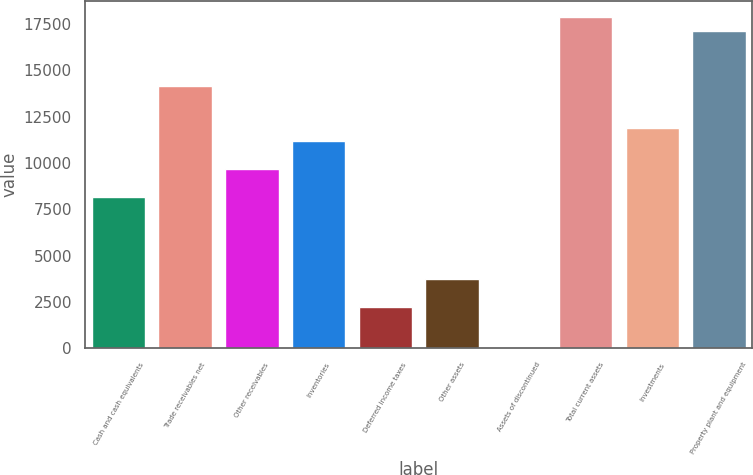<chart> <loc_0><loc_0><loc_500><loc_500><bar_chart><fcel>Cash and cash equivalents<fcel>Trade receivables net<fcel>Other receivables<fcel>Inventories<fcel>Deferred income taxes<fcel>Other assets<fcel>Assets of discontinued<fcel>Total current assets<fcel>Investments<fcel>Property plant and equipment<nl><fcel>8189.3<fcel>14143.7<fcel>9677.9<fcel>11166.5<fcel>2234.9<fcel>3723.5<fcel>2<fcel>17865.2<fcel>11910.8<fcel>17120.9<nl></chart> 